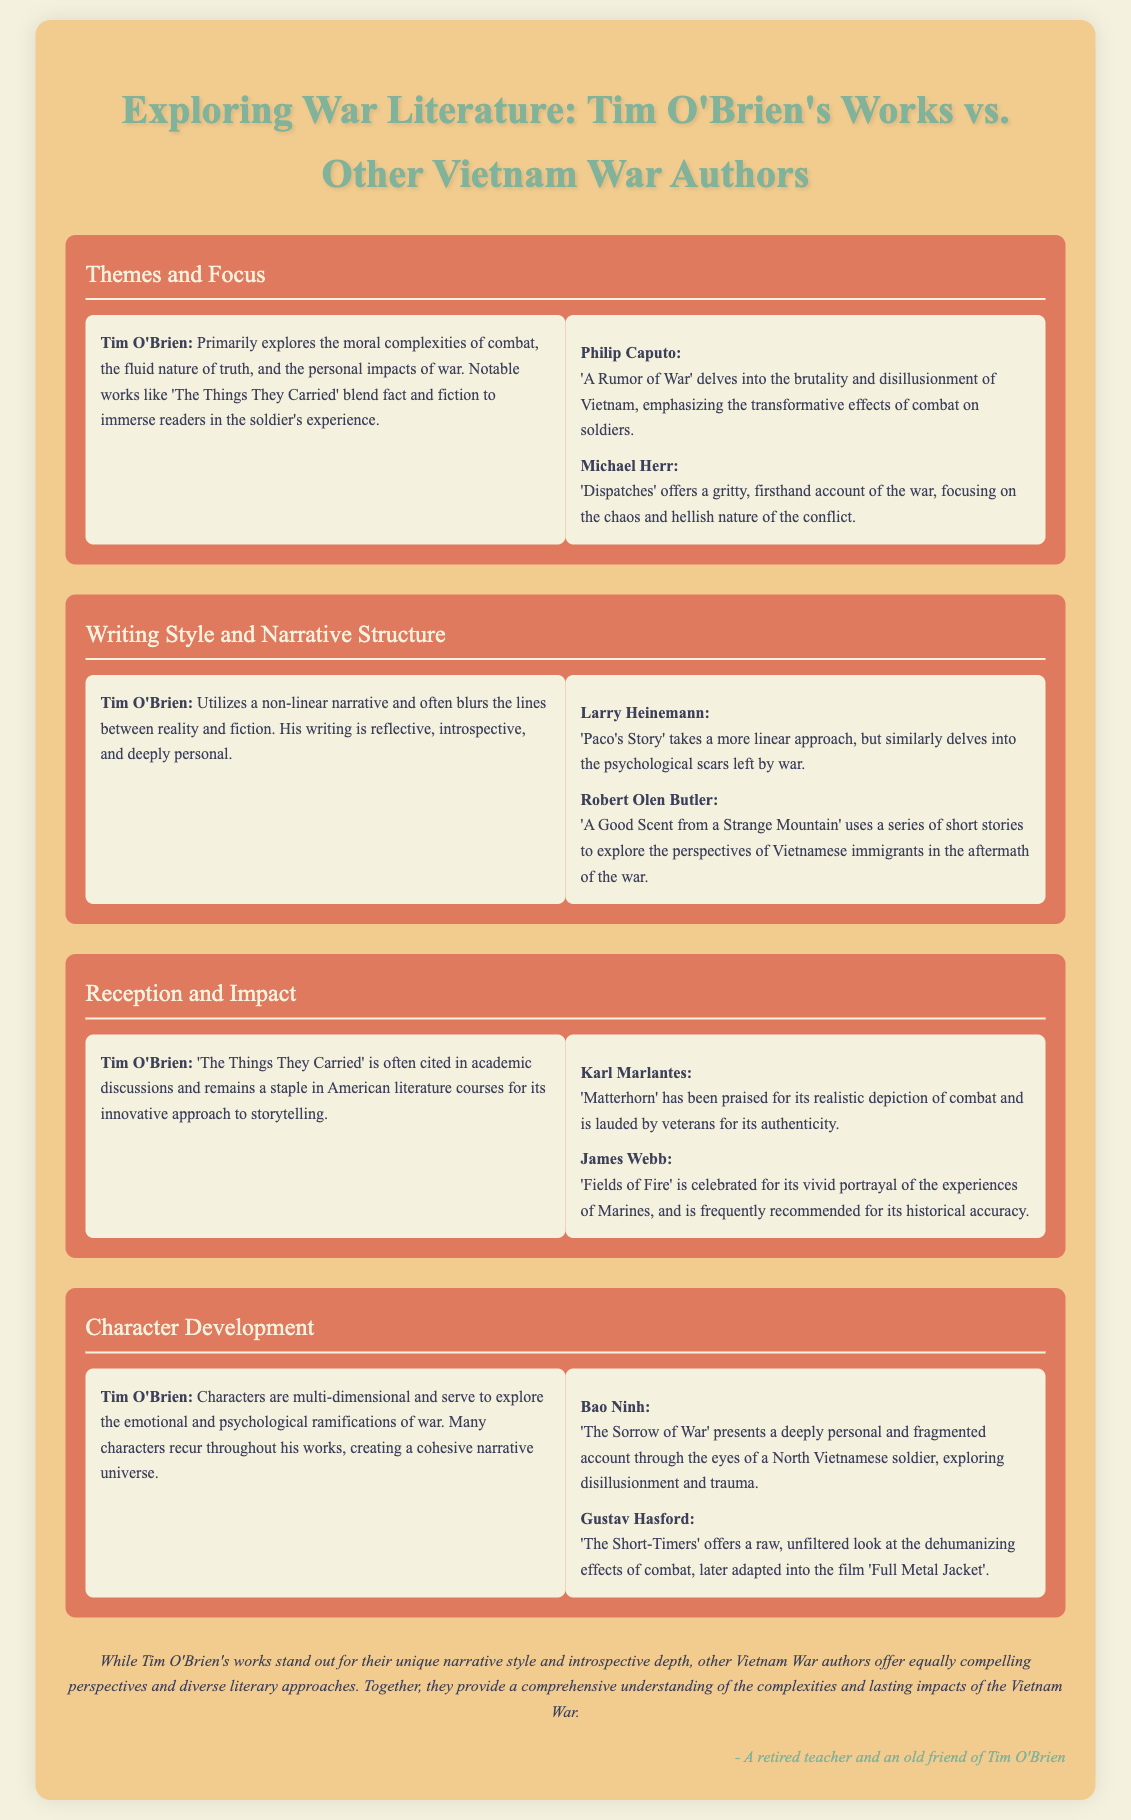What are the notable works of Tim O'Brien? The document mentions 'The Things They Carried' as a notable work of Tim O'Brien that blends fact and fiction.
Answer: 'The Things They Carried' What theme does Tim O'Brien primarily explore? The document states that O'Brien primarily explores the moral complexities of combat, the fluid nature of truth, and the personal impacts of war.
Answer: Moral complexities of combat Which author wrote 'A Rumor of War'? The document identifies Philip Caputo as the author of 'A Rumor of War'.
Answer: Philip Caputo What narrative technique does Tim O'Brien utilize? The document mentions that Tim O'Brien utilizes a non-linear narrative and blurs the lines between reality and fiction.
Answer: Non-linear narrative Which book is praised for its realistic depiction of combat? The document states that 'Matterhorn' by Karl Marlantes has been praised for its realistic depiction of combat.
Answer: Matterhorn How are characters developed in Tim O'Brien's works? The document explains that characters in O'Brien's works are multi-dimensional and explore the emotional and psychological ramifications of war.
Answer: Multi-dimensional Which author presented a fragmented account through the eyes of a soldier? The document mentions Bao Ninh as the author who presents a fragmented account in 'The Sorrow of War'.
Answer: Bao Ninh What is the conclusion about Tim O'Brien's works compared to other authors? The document concludes that O'Brien's works stand out for their narrative style and introspective depth, while other authors offer compelling perspectives.
Answer: Unique narrative style and introspective depth What author used a series of short stories to explore Vietnamese perspectives? The document identifies Robert Olen Butler as the author who used short stories in 'A Good Scent from a Strange Mountain'.
Answer: Robert Olen Butler 